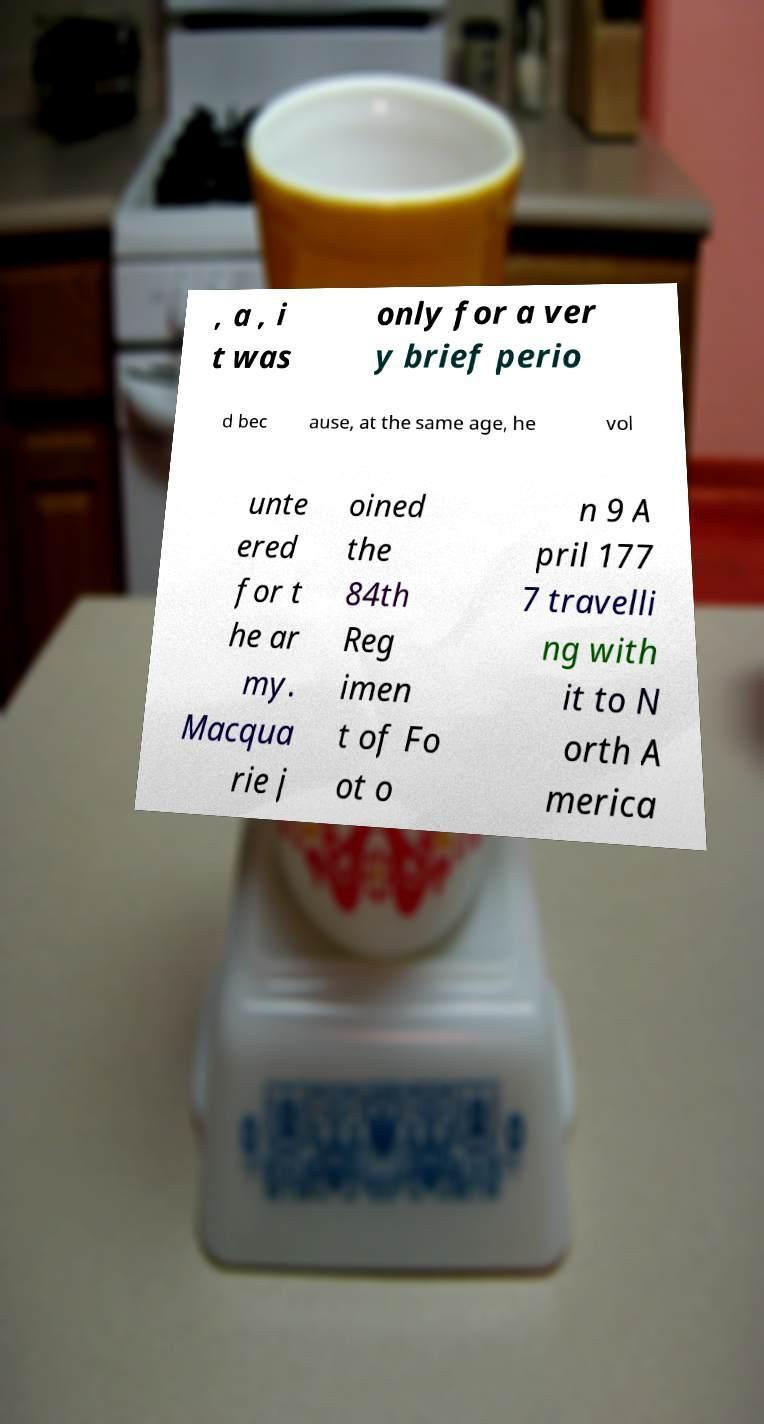What messages or text are displayed in this image? I need them in a readable, typed format. , a , i t was only for a ver y brief perio d bec ause, at the same age, he vol unte ered for t he ar my. Macqua rie j oined the 84th Reg imen t of Fo ot o n 9 A pril 177 7 travelli ng with it to N orth A merica 